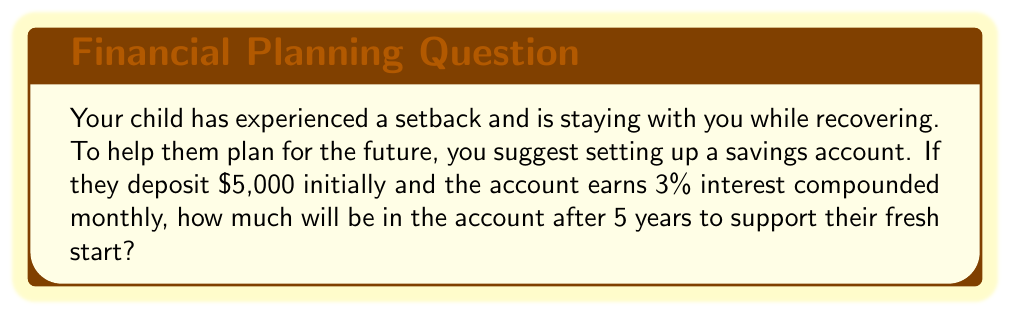Help me with this question. Let's approach this step-by-step using the compound interest formula:

$$A = P(1 + \frac{r}{n})^{nt}$$

Where:
$A$ = final amount
$P$ = principal (initial investment)
$r$ = annual interest rate (in decimal form)
$n$ = number of times interest is compounded per year
$t$ = number of years

Given:
$P = \$5,000$
$r = 0.03$ (3% expressed as a decimal)
$n = 12$ (compounded monthly)
$t = 5$ years

Let's plug these values into the formula:

$$A = 5000(1 + \frac{0.03}{12})^{12 \cdot 5}$$

$$A = 5000(1 + 0.0025)^{60}$$

$$A = 5000(1.0025)^{60}$$

Using a calculator:

$$A = 5000 \cdot 1.16140$$

$$A = 5807.00$$

Therefore, after 5 years, the account will contain $5,807.00.
Answer: $5,807.00 